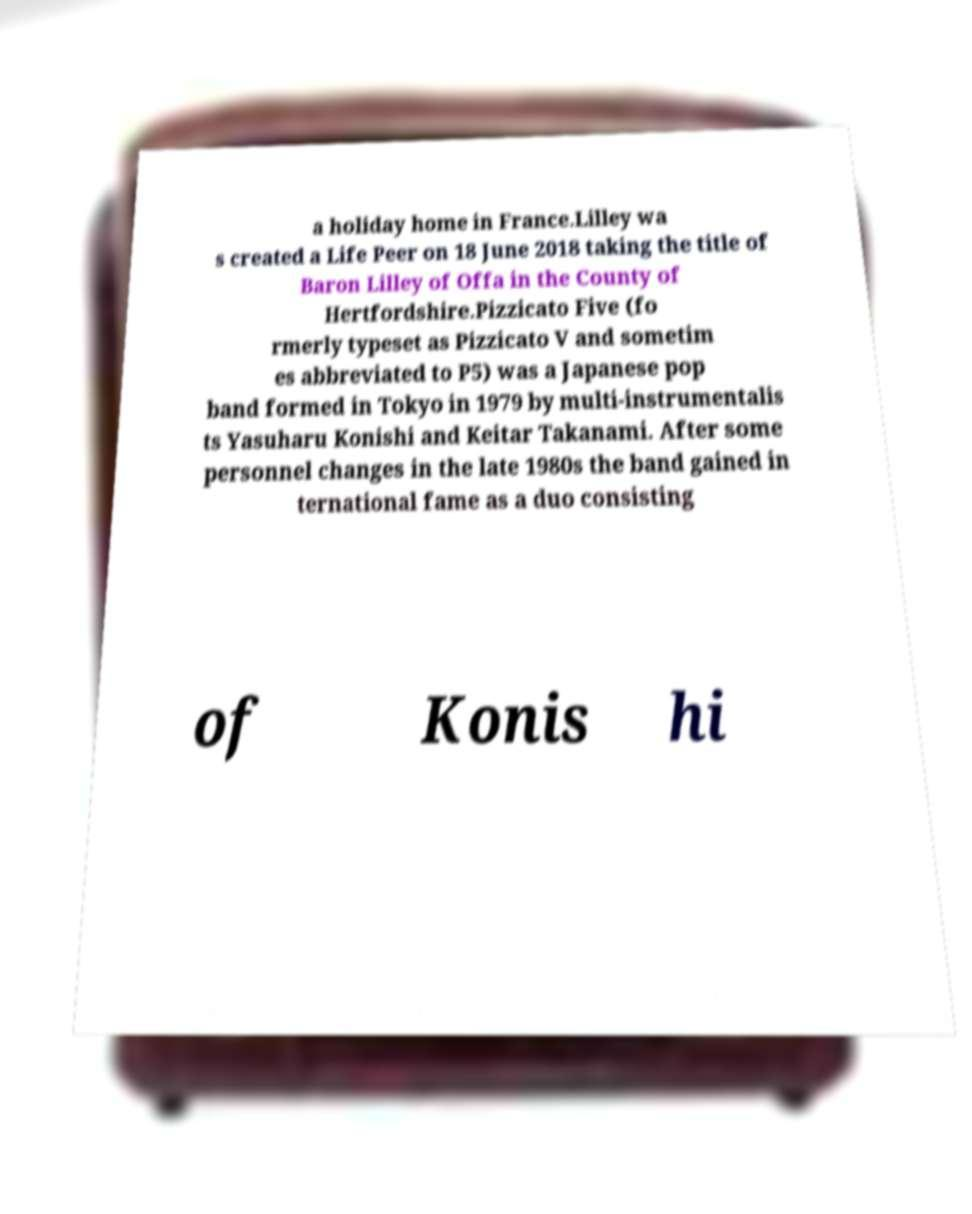For documentation purposes, I need the text within this image transcribed. Could you provide that? a holiday home in France.Lilley wa s created a Life Peer on 18 June 2018 taking the title of Baron Lilley of Offa in the County of Hertfordshire.Pizzicato Five (fo rmerly typeset as Pizzicato V and sometim es abbreviated to P5) was a Japanese pop band formed in Tokyo in 1979 by multi-instrumentalis ts Yasuharu Konishi and Keitar Takanami. After some personnel changes in the late 1980s the band gained in ternational fame as a duo consisting of Konis hi 